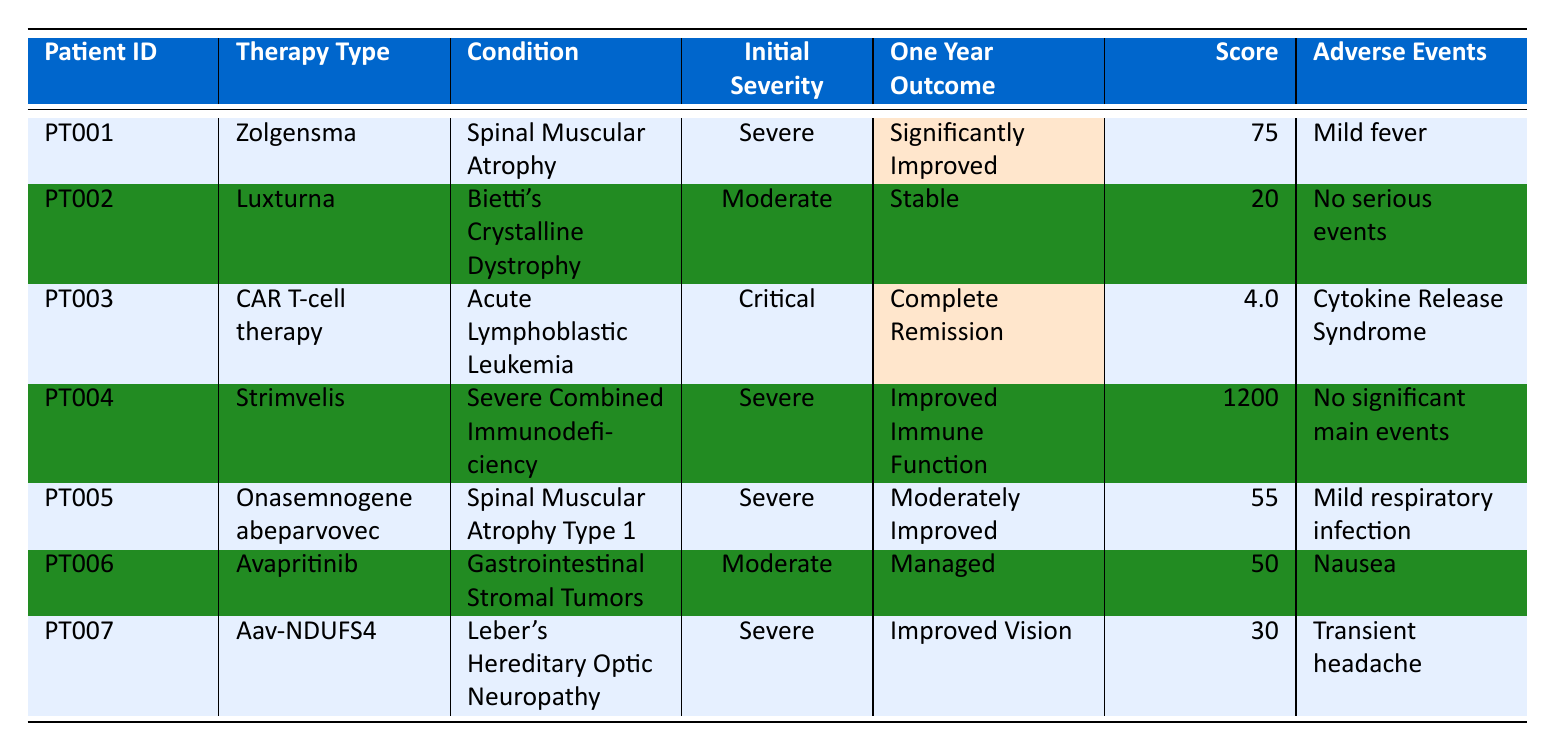What is the one-year outcome for patient PT001? The row for patient PT001 indicates that the one-year outcome is "Significantly Improved."
Answer: Significantly Improved How many patients had a therapy outcome categorized as "Stable"? In the table, only one patient, PT002, has a one-year outcome classified as "Stable."
Answer: 1 Which therapy led to "Complete Remission"? The therapy type for patient PT003 is "CAR T-cell therapy," which resulted in "Complete Remission."
Answer: CAR T-cell therapy What was the motor function score for patient PT005? For patient PT005, the motor function score is displayed as 55.
Answer: 55 Did any patients experience no serious adverse events? Patient PT002 has "No serious events" listed among the adverse events, indicating that at least one patient experienced no serious adverse events.
Answer: Yes What is the average motor function score of patients who had severe initial conditions? The motor function scores for PT001 (75) and PT005 (55) are considered since both had severe initial conditions. The average is (75 + 55) / 2 = 65.
Answer: 65 How many patients were treated for Spinal Muscular Atrophy, and what were their outcomes? Two patients (PT001 and PT005) were treated for Spinal Muscular Atrophy; their outcomes were "Significantly Improved" and "Moderately Improved," respectively.
Answer: 2 patients; outcomes are "Significantly Improved" and "Moderately Improved" Which patient showed the highest score among those listed? Reviewing the scores, patient PT004 has a score of 1200, which is the highest among all.
Answer: PT004 Did any patients have "Improved Immune Function" as an outcome? Yes, patient PT004 had "Improved Immune Function" as the one-year outcome.
Answer: Yes What condition had the critical initial severity, and what was the one-year outcome? The condition with critical initial severity is "Acute Lymphoblastic Leukemia," and the one-year outcome for patient PT003 was "Complete Remission."
Answer: Acute Lymphoblastic Leukemia; outcome was "Complete Remission" 